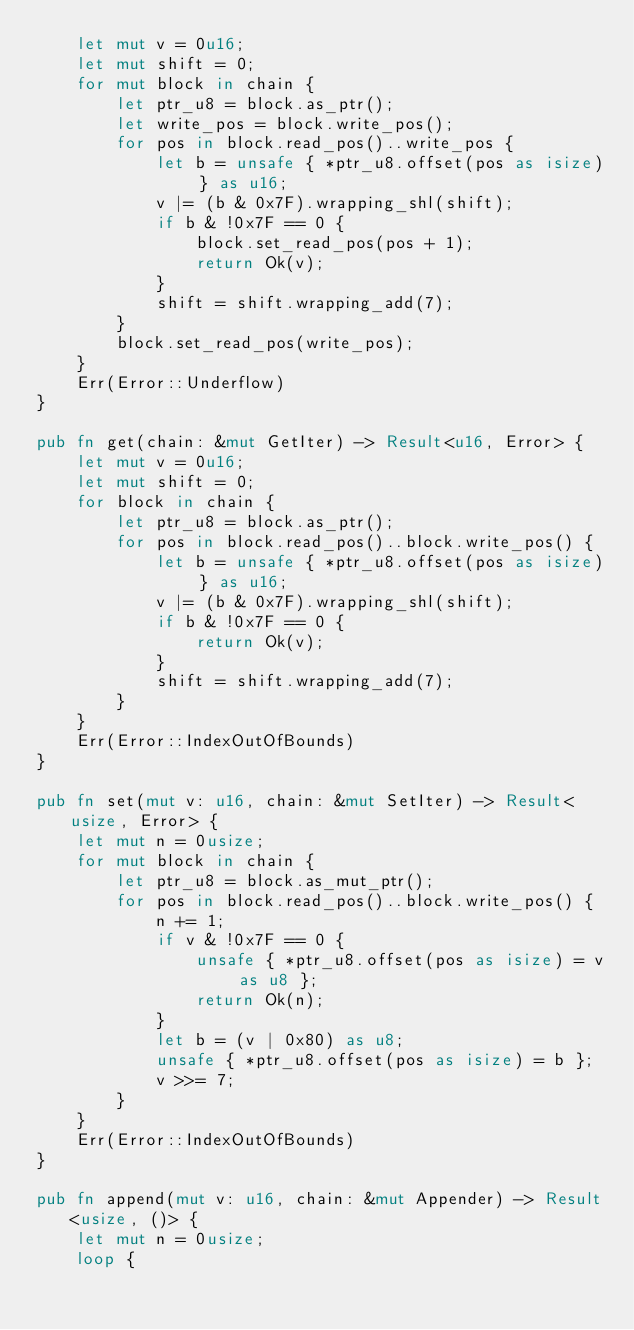<code> <loc_0><loc_0><loc_500><loc_500><_Rust_>    let mut v = 0u16;
    let mut shift = 0;
    for mut block in chain {
        let ptr_u8 = block.as_ptr();
        let write_pos = block.write_pos();
        for pos in block.read_pos()..write_pos {
            let b = unsafe { *ptr_u8.offset(pos as isize) } as u16;
            v |= (b & 0x7F).wrapping_shl(shift);
            if b & !0x7F == 0 {
                block.set_read_pos(pos + 1);
                return Ok(v);
            }
            shift = shift.wrapping_add(7);
        }
        block.set_read_pos(write_pos);
    }
    Err(Error::Underflow)
}

pub fn get(chain: &mut GetIter) -> Result<u16, Error> {
    let mut v = 0u16;
    let mut shift = 0;
    for block in chain {
        let ptr_u8 = block.as_ptr();
        for pos in block.read_pos()..block.write_pos() {
            let b = unsafe { *ptr_u8.offset(pos as isize) } as u16;
            v |= (b & 0x7F).wrapping_shl(shift);
            if b & !0x7F == 0 {
                return Ok(v);
            }
            shift = shift.wrapping_add(7);
        }
    }
    Err(Error::IndexOutOfBounds)
}

pub fn set(mut v: u16, chain: &mut SetIter) -> Result<usize, Error> {
    let mut n = 0usize;
    for mut block in chain {
        let ptr_u8 = block.as_mut_ptr();
        for pos in block.read_pos()..block.write_pos() {
            n += 1;
            if v & !0x7F == 0 {
                unsafe { *ptr_u8.offset(pos as isize) = v as u8 };
                return Ok(n);
            }
            let b = (v | 0x80) as u8;
            unsafe { *ptr_u8.offset(pos as isize) = b };
            v >>= 7;
        }
    }
    Err(Error::IndexOutOfBounds)
}

pub fn append(mut v: u16, chain: &mut Appender) -> Result<usize, ()> {
    let mut n = 0usize;
    loop {</code> 